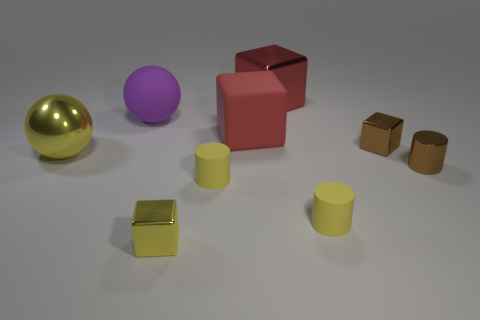Add 1 red blocks. How many objects exist? 10 Subtract all cubes. How many objects are left? 5 Subtract 0 gray cylinders. How many objects are left? 9 Subtract all big red objects. Subtract all big red cubes. How many objects are left? 5 Add 2 yellow cylinders. How many yellow cylinders are left? 4 Add 1 red rubber blocks. How many red rubber blocks exist? 2 